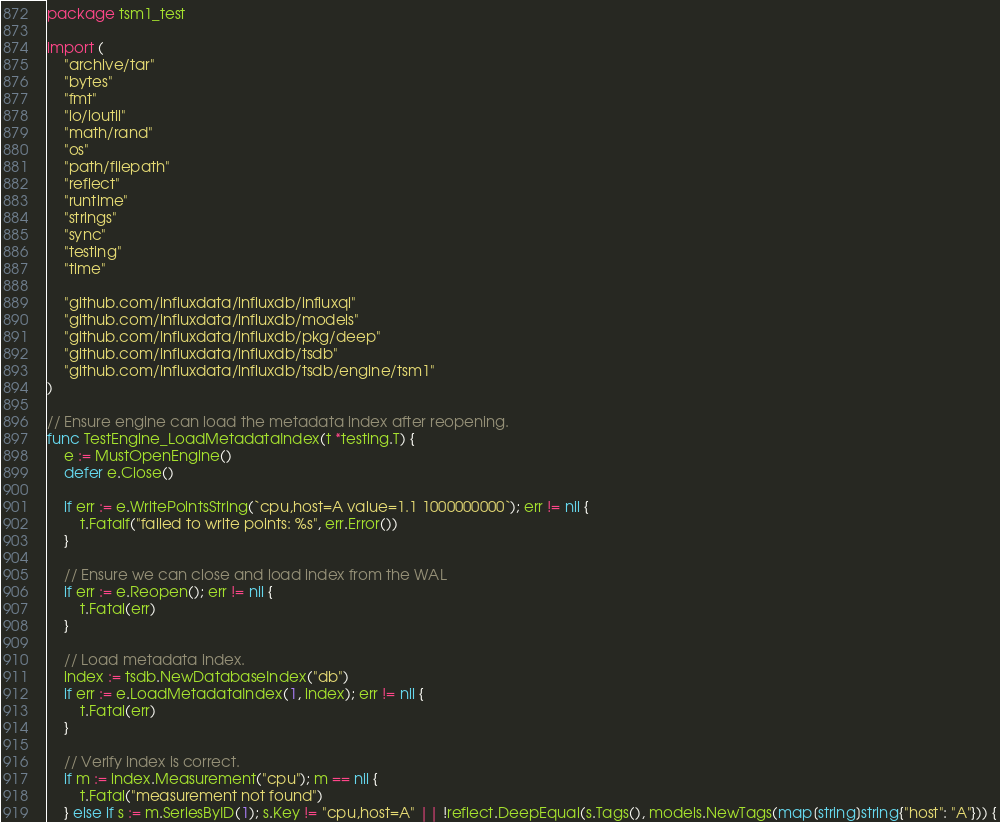<code> <loc_0><loc_0><loc_500><loc_500><_Go_>package tsm1_test

import (
	"archive/tar"
	"bytes"
	"fmt"
	"io/ioutil"
	"math/rand"
	"os"
	"path/filepath"
	"reflect"
	"runtime"
	"strings"
	"sync"
	"testing"
	"time"

	"github.com/influxdata/influxdb/influxql"
	"github.com/influxdata/influxdb/models"
	"github.com/influxdata/influxdb/pkg/deep"
	"github.com/influxdata/influxdb/tsdb"
	"github.com/influxdata/influxdb/tsdb/engine/tsm1"
)

// Ensure engine can load the metadata index after reopening.
func TestEngine_LoadMetadataIndex(t *testing.T) {
	e := MustOpenEngine()
	defer e.Close()

	if err := e.WritePointsString(`cpu,host=A value=1.1 1000000000`); err != nil {
		t.Fatalf("failed to write points: %s", err.Error())
	}

	// Ensure we can close and load index from the WAL
	if err := e.Reopen(); err != nil {
		t.Fatal(err)
	}

	// Load metadata index.
	index := tsdb.NewDatabaseIndex("db")
	if err := e.LoadMetadataIndex(1, index); err != nil {
		t.Fatal(err)
	}

	// Verify index is correct.
	if m := index.Measurement("cpu"); m == nil {
		t.Fatal("measurement not found")
	} else if s := m.SeriesByID(1); s.Key != "cpu,host=A" || !reflect.DeepEqual(s.Tags(), models.NewTags(map[string]string{"host": "A"})) {</code> 